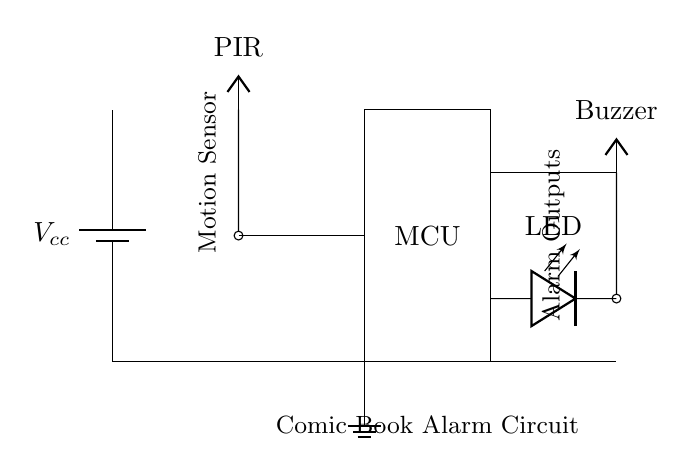What type of sensor is used in this circuit? The circuit uses a PIR sensor, which is indicated in the circuit by the label "PIR" and its connection to the microcontroller.
Answer: PIR sensor What does the LED in the circuit signify? The LED serves as an indicator for the alarm being activated. It is connected in such a way that when the buzzer sounds, the LED also lights up.
Answer: Alarm indicator How many key components are there in the circuit? The circuit has four main components: the PIR sensor, microcontroller, buzzer, and LED. Each component is essential for the functionality of the motion-sensing alarm.
Answer: Four What is the function of the buzzer in this alarm circuit? The buzzer emits sound when the motion is detected by the PIR sensor, acting as an audio alarm to alert the owner of any unauthorized access.
Answer: Audio alarm Which component provides power to the circuit? The circuit is powered by a battery, as depicted by the battery symbol labeled "Vcc" at the top of the diagram, which supplies the necessary voltage for the other components.
Answer: Battery What type of output does the circuit generate when motion is detected? When motion is detected, the circuit generates an alarm output that is both auditory (from the buzzer) and visual (from the LED), indicating the alarm status.
Answer: Audio and visual alarm 